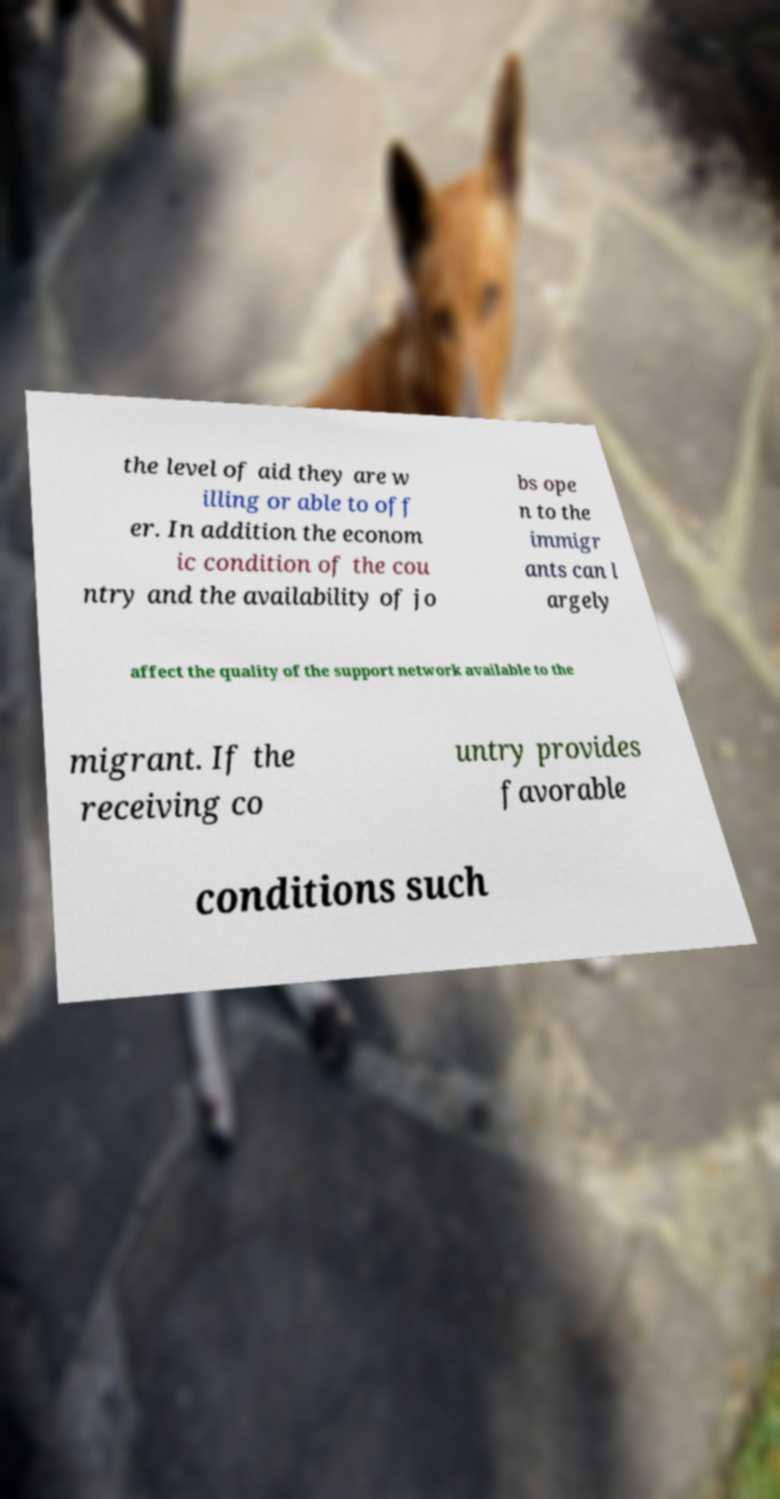Please identify and transcribe the text found in this image. the level of aid they are w illing or able to off er. In addition the econom ic condition of the cou ntry and the availability of jo bs ope n to the immigr ants can l argely affect the quality of the support network available to the migrant. If the receiving co untry provides favorable conditions such 